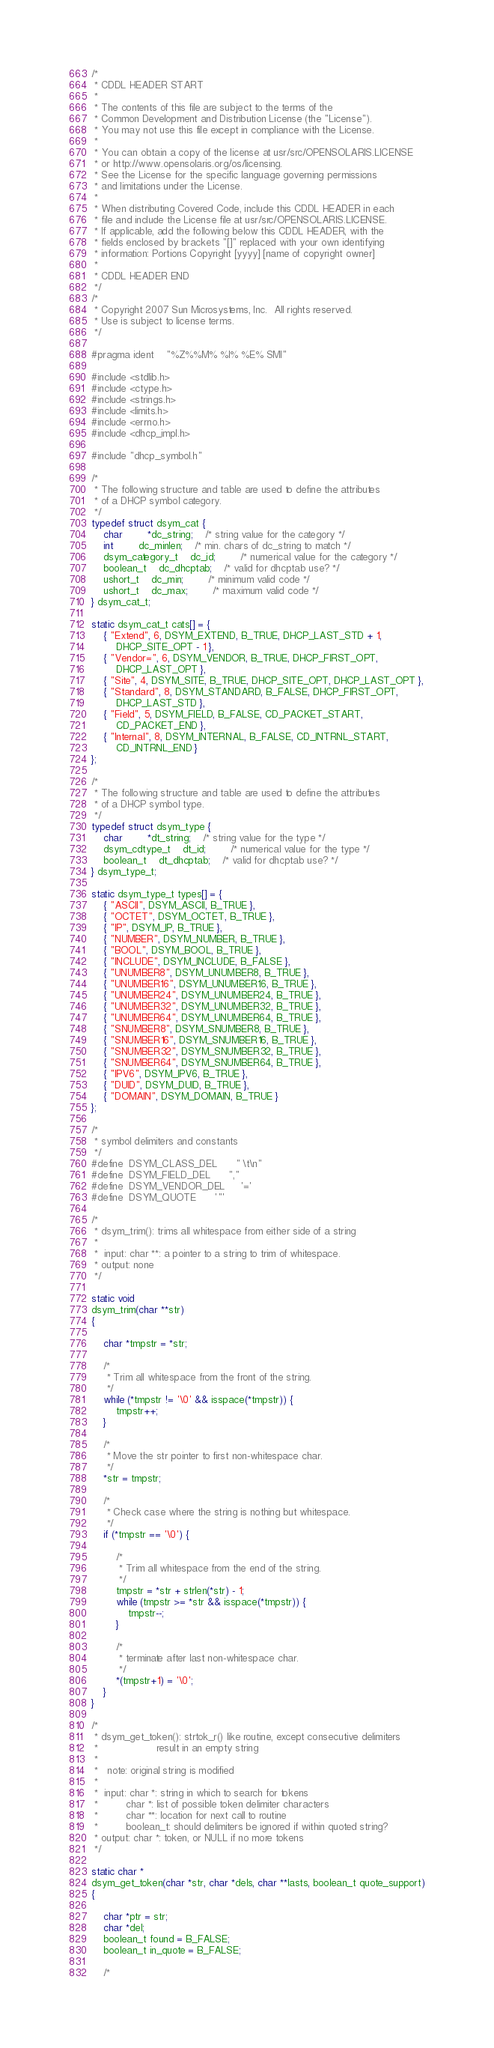<code> <loc_0><loc_0><loc_500><loc_500><_C_>/*
 * CDDL HEADER START
 *
 * The contents of this file are subject to the terms of the
 * Common Development and Distribution License (the "License").
 * You may not use this file except in compliance with the License.
 *
 * You can obtain a copy of the license at usr/src/OPENSOLARIS.LICENSE
 * or http://www.opensolaris.org/os/licensing.
 * See the License for the specific language governing permissions
 * and limitations under the License.
 *
 * When distributing Covered Code, include this CDDL HEADER in each
 * file and include the License file at usr/src/OPENSOLARIS.LICENSE.
 * If applicable, add the following below this CDDL HEADER, with the
 * fields enclosed by brackets "[]" replaced with your own identifying
 * information: Portions Copyright [yyyy] [name of copyright owner]
 *
 * CDDL HEADER END
 */
/*
 * Copyright 2007 Sun Microsystems, Inc.  All rights reserved.
 * Use is subject to license terms.
 */

#pragma ident	"%Z%%M%	%I%	%E% SMI"

#include <stdlib.h>
#include <ctype.h>
#include <strings.h>
#include <limits.h>
#include <errno.h>
#include <dhcp_impl.h>

#include "dhcp_symbol.h"

/*
 * The following structure and table are used to define the attributes
 * of a DHCP symbol category.
 */
typedef struct dsym_cat {
	char		*dc_string;	/* string value for the category */
	int		dc_minlen;	/* min. chars of dc_string to match */
	dsym_category_t	dc_id;		/* numerical value for the category */
	boolean_t	dc_dhcptab;	/* valid for dhcptab use? */
	ushort_t	dc_min;		/* minimum valid code */
	ushort_t	dc_max;		/* maximum valid code */
} dsym_cat_t;

static dsym_cat_t cats[] = {
	{ "Extend", 6, DSYM_EXTEND, B_TRUE, DHCP_LAST_STD + 1,
		DHCP_SITE_OPT - 1 },
	{ "Vendor=", 6, DSYM_VENDOR, B_TRUE, DHCP_FIRST_OPT,
		DHCP_LAST_OPT },
	{ "Site", 4, DSYM_SITE, B_TRUE, DHCP_SITE_OPT, DHCP_LAST_OPT },
	{ "Standard", 8, DSYM_STANDARD, B_FALSE, DHCP_FIRST_OPT,
	    DHCP_LAST_STD },
	{ "Field", 5, DSYM_FIELD, B_FALSE, CD_PACKET_START,
		CD_PACKET_END },
	{ "Internal", 8, DSYM_INTERNAL, B_FALSE, CD_INTRNL_START,
	    CD_INTRNL_END }
};

/*
 * The following structure and table are used to define the attributes
 * of a DHCP symbol type.
 */
typedef struct dsym_type {
	char		*dt_string;	/* string value for the type */
	dsym_cdtype_t	dt_id;		/* numerical value for the type */
	boolean_t	dt_dhcptab;	/* valid for dhcptab use? */
} dsym_type_t;

static dsym_type_t types[] = {
	{ "ASCII", DSYM_ASCII, B_TRUE },
	{ "OCTET", DSYM_OCTET, B_TRUE },
	{ "IP", DSYM_IP, B_TRUE },
	{ "NUMBER", DSYM_NUMBER, B_TRUE },
	{ "BOOL", DSYM_BOOL, B_TRUE },
	{ "INCLUDE", DSYM_INCLUDE, B_FALSE },
	{ "UNUMBER8", DSYM_UNUMBER8, B_TRUE },
	{ "UNUMBER16", DSYM_UNUMBER16, B_TRUE },
	{ "UNUMBER24", DSYM_UNUMBER24, B_TRUE },
	{ "UNUMBER32", DSYM_UNUMBER32, B_TRUE },
	{ "UNUMBER64", DSYM_UNUMBER64, B_TRUE },
	{ "SNUMBER8", DSYM_SNUMBER8, B_TRUE },
	{ "SNUMBER16", DSYM_SNUMBER16, B_TRUE },
	{ "SNUMBER32", DSYM_SNUMBER32, B_TRUE },
	{ "SNUMBER64", DSYM_SNUMBER64, B_TRUE },
	{ "IPV6", DSYM_IPV6, B_TRUE },
	{ "DUID", DSYM_DUID, B_TRUE },
	{ "DOMAIN", DSYM_DOMAIN, B_TRUE }
};

/*
 * symbol delimiters and constants
 */
#define	DSYM_CLASS_DEL		" \t\n"
#define	DSYM_FIELD_DEL		","
#define	DSYM_VENDOR_DEL		'='
#define	DSYM_QUOTE		'"'

/*
 * dsym_trim(): trims all whitespace from either side of a string
 *
 *  input: char **: a pointer to a string to trim of whitespace.
 * output: none
 */

static void
dsym_trim(char **str)
{

	char *tmpstr = *str;

	/*
	 * Trim all whitespace from the front of the string.
	 */
	while (*tmpstr != '\0' && isspace(*tmpstr)) {
		tmpstr++;
	}

	/*
	 * Move the str pointer to first non-whitespace char.
	 */
	*str = tmpstr;

	/*
	 * Check case where the string is nothing but whitespace.
	 */
	if (*tmpstr == '\0') {

		/*
		 * Trim all whitespace from the end of the string.
		 */
		tmpstr = *str + strlen(*str) - 1;
		while (tmpstr >= *str && isspace(*tmpstr)) {
			tmpstr--;
		}

		/*
		 * terminate after last non-whitespace char.
		 */
		*(tmpstr+1) = '\0';
	}
}

/*
 * dsym_get_token(): strtok_r() like routine, except consecutive delimiters
 *                   result in an empty string
 *
 *   note: original string is modified
 *
 *  input: char *: string in which to search for tokens
 *         char *: list of possible token delimiter characters
 *         char **: location for next call to routine
 *         boolean_t: should delimiters be ignored if within quoted string?
 * output: char *: token, or NULL if no more tokens
 */

static char *
dsym_get_token(char *str, char *dels, char **lasts, boolean_t quote_support)
{

	char *ptr = str;
	char *del;
	boolean_t found = B_FALSE;
	boolean_t in_quote = B_FALSE;

	/*</code> 